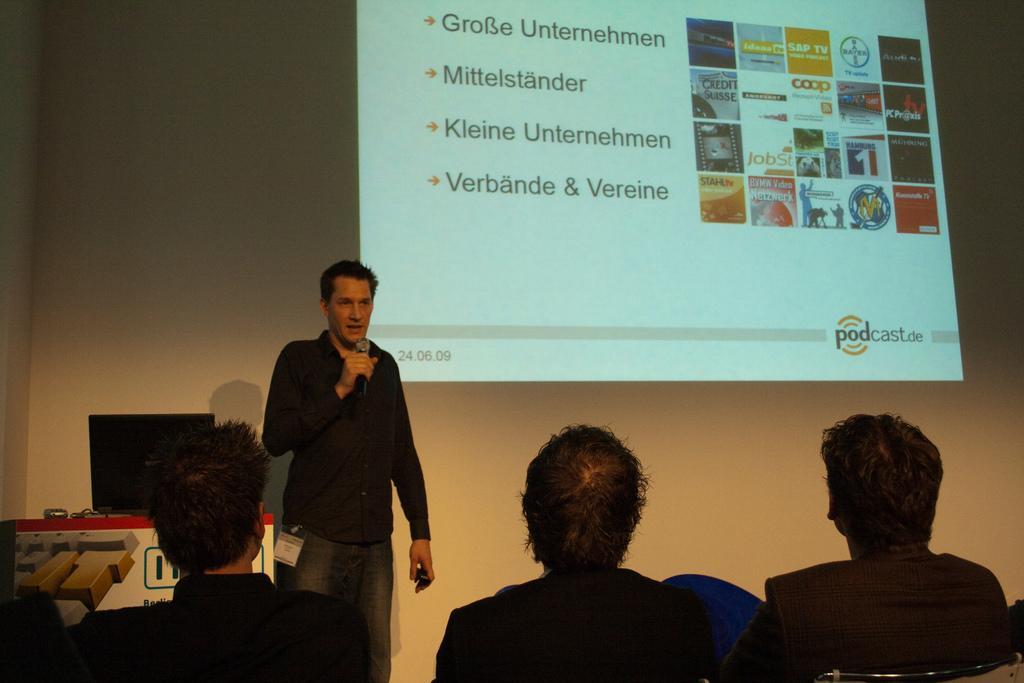Can you describe this image briefly? There is a person wearing black dress is standing and speaking in front of a mic and there are there is a laptop beside him and there are few persons sitting in front of him and there is a projected image in the background. 